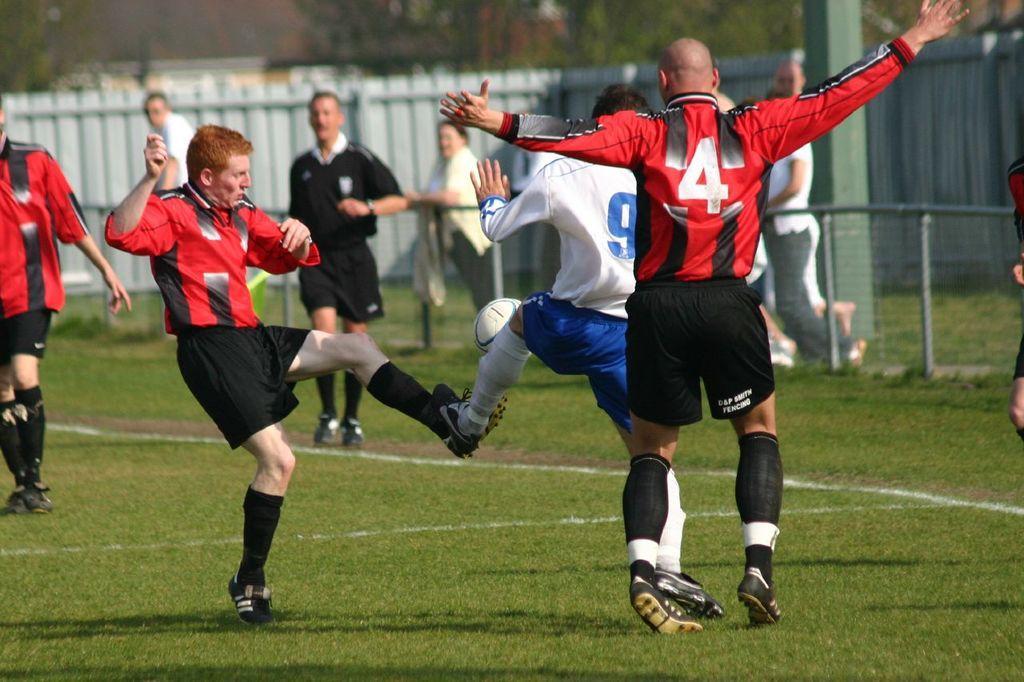Could you give a brief overview of what you see in this image? In this image I can see group of people playing game. In front the person is wearing black and red color dress and the person at left is wearing white and blue color dress and I can see a ball in white color. Background I can see a shed and I can see trees in green color. 